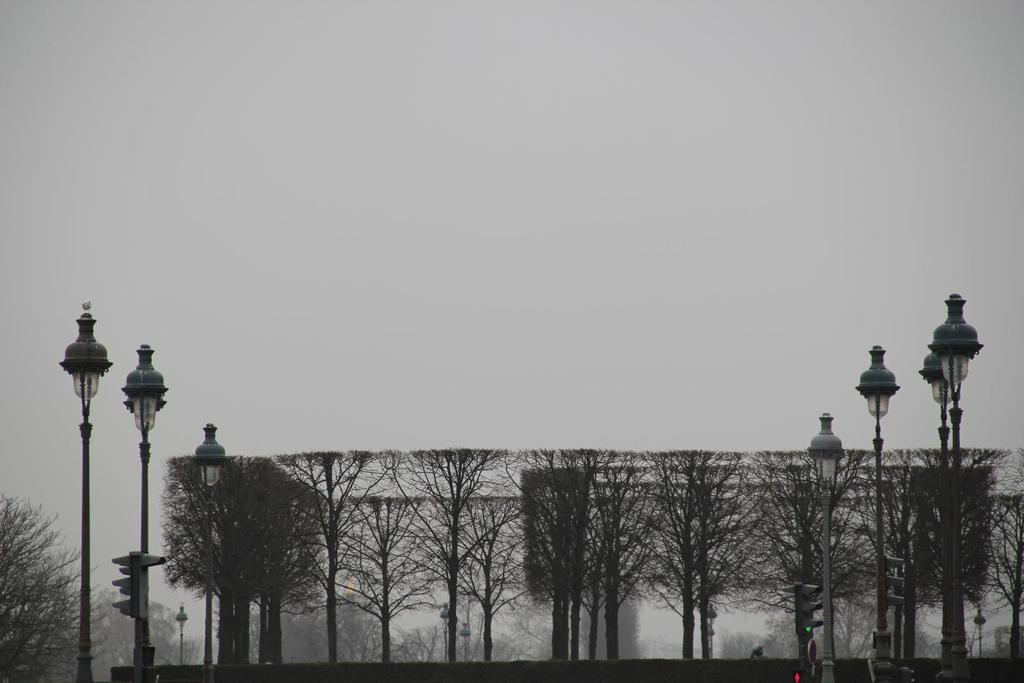What type of vegetation can be seen in the image? There are trees in the image. What objects are in front of the trees? There are lamps in front of the trees. What can be seen in the background of the image? The sky is visible in the background of the image. What color is the tramp in the image? There is no tramp present in the image. Why is the person in the image crying? There is no person present in the image, and therefore no one is crying. 